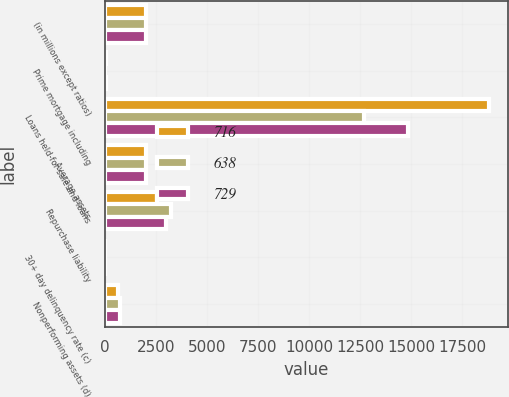Convert chart. <chart><loc_0><loc_0><loc_500><loc_500><stacked_bar_chart><ecel><fcel>(in millions except ratios)<fcel>Prime mortgage including<fcel>Loans held-for-sale and loans<fcel>Average assets<fcel>Repurchase liability<fcel>30+ day delinquency rate (c)<fcel>Nonperforming assets (d)<nl><fcel>716<fcel>2012<fcel>19<fcel>18801<fcel>2011<fcel>2530<fcel>3.05<fcel>638<nl><fcel>638<fcel>2011<fcel>5<fcel>12694<fcel>2011<fcel>3213<fcel>3.15<fcel>716<nl><fcel>729<fcel>2010<fcel>41<fcel>14863<fcel>2011<fcel>3000<fcel>3.44<fcel>729<nl></chart> 